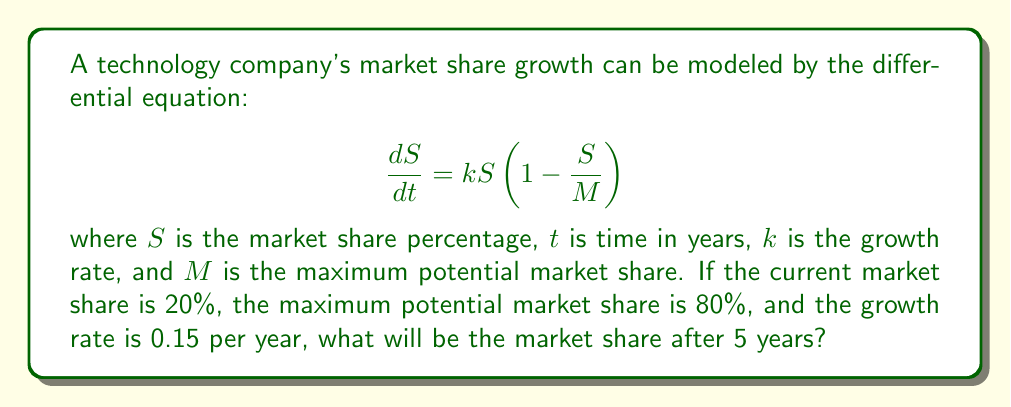Give your solution to this math problem. To solve this problem, we need to use the logistic growth model, which is represented by the given differential equation. This model is commonly used in business forecasting to predict market trends.

1. First, let's identify the given values:
   - Initial market share: $S_0 = 20\% = 0.2$
   - Maximum potential market share: $M = 80\% = 0.8$
   - Growth rate: $k = 0.15$
   - Time period: $t = 5$ years

2. The solution to the logistic growth differential equation is:

   $$S(t) = \frac{M}{1 + (\frac{M}{S_0} - 1)e^{-kt}}$$

3. Let's substitute the known values into this equation:

   $$S(5) = \frac{0.8}{1 + (\frac{0.8}{0.2} - 1)e^{-0.15 \cdot 5}}$$

4. Simplify the expression inside the parentheses:
   
   $$S(5) = \frac{0.8}{1 + (4 - 1)e^{-0.75}}$$
   
   $$S(5) = \frac{0.8}{1 + 3e^{-0.75}}$$

5. Calculate $e^{-0.75}$:
   
   $$S(5) = \frac{0.8}{1 + 3 \cdot 0.4724}$$

6. Simplify:
   
   $$S(5) = \frac{0.8}{1 + 1.4172}$$
   
   $$S(5) = \frac{0.8}{2.4172}$$

7. Calculate the final result:
   
   $$S(5) = 0.3309$$

8. Convert to percentage:
   
   $$S(5) = 33.09\%$$

Therefore, after 5 years, the market share will be approximately 33.09%.
Answer: 33.09% 